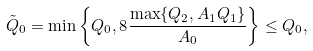Convert formula to latex. <formula><loc_0><loc_0><loc_500><loc_500>\tilde { Q } _ { 0 } = \min \left \{ Q _ { 0 } , 8 \frac { \max \{ Q _ { 2 } , A _ { 1 } Q _ { 1 } \} } { A _ { 0 } } \right \} \leq Q _ { 0 } ,</formula> 